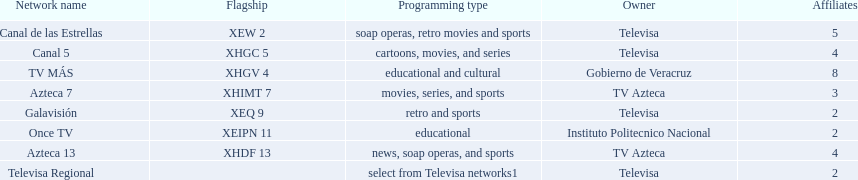What is the number of networks that broadcast soap operas? 2. 